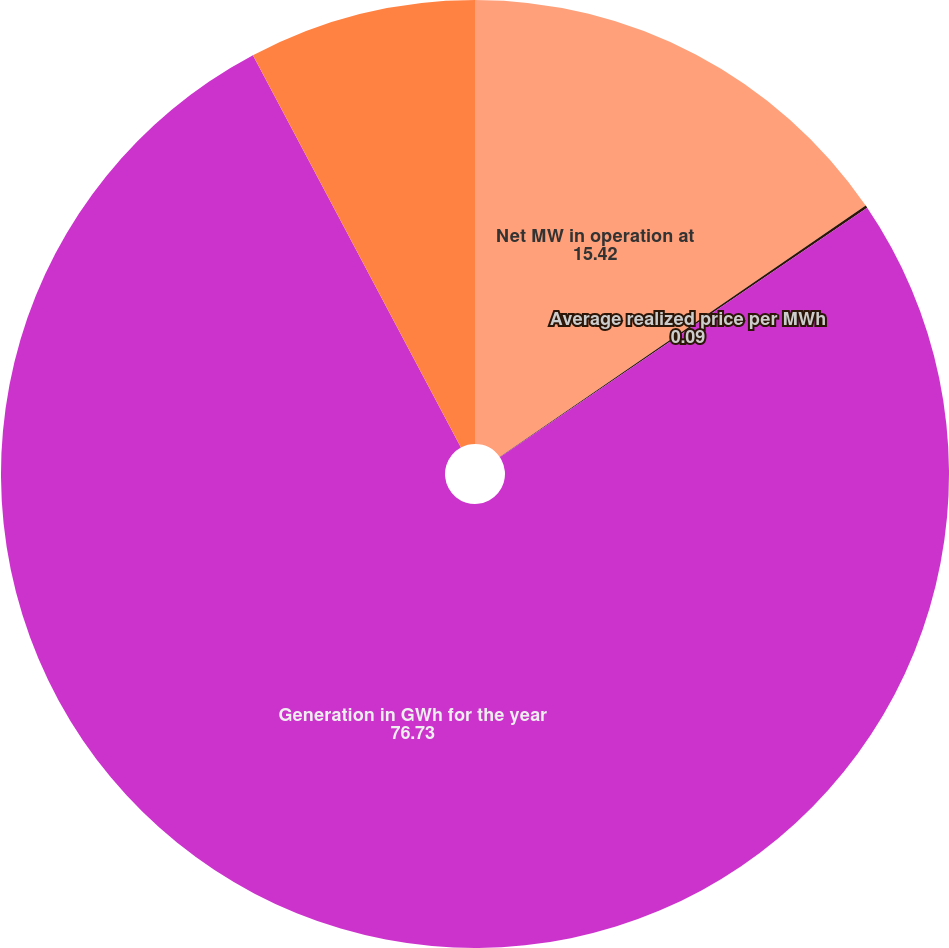Convert chart to OTSL. <chart><loc_0><loc_0><loc_500><loc_500><pie_chart><fcel>Net MW in operation at<fcel>Average realized price per MWh<fcel>Generation in GWh for the year<fcel>Capacity factor for the year<nl><fcel>15.42%<fcel>0.09%<fcel>76.73%<fcel>7.76%<nl></chart> 